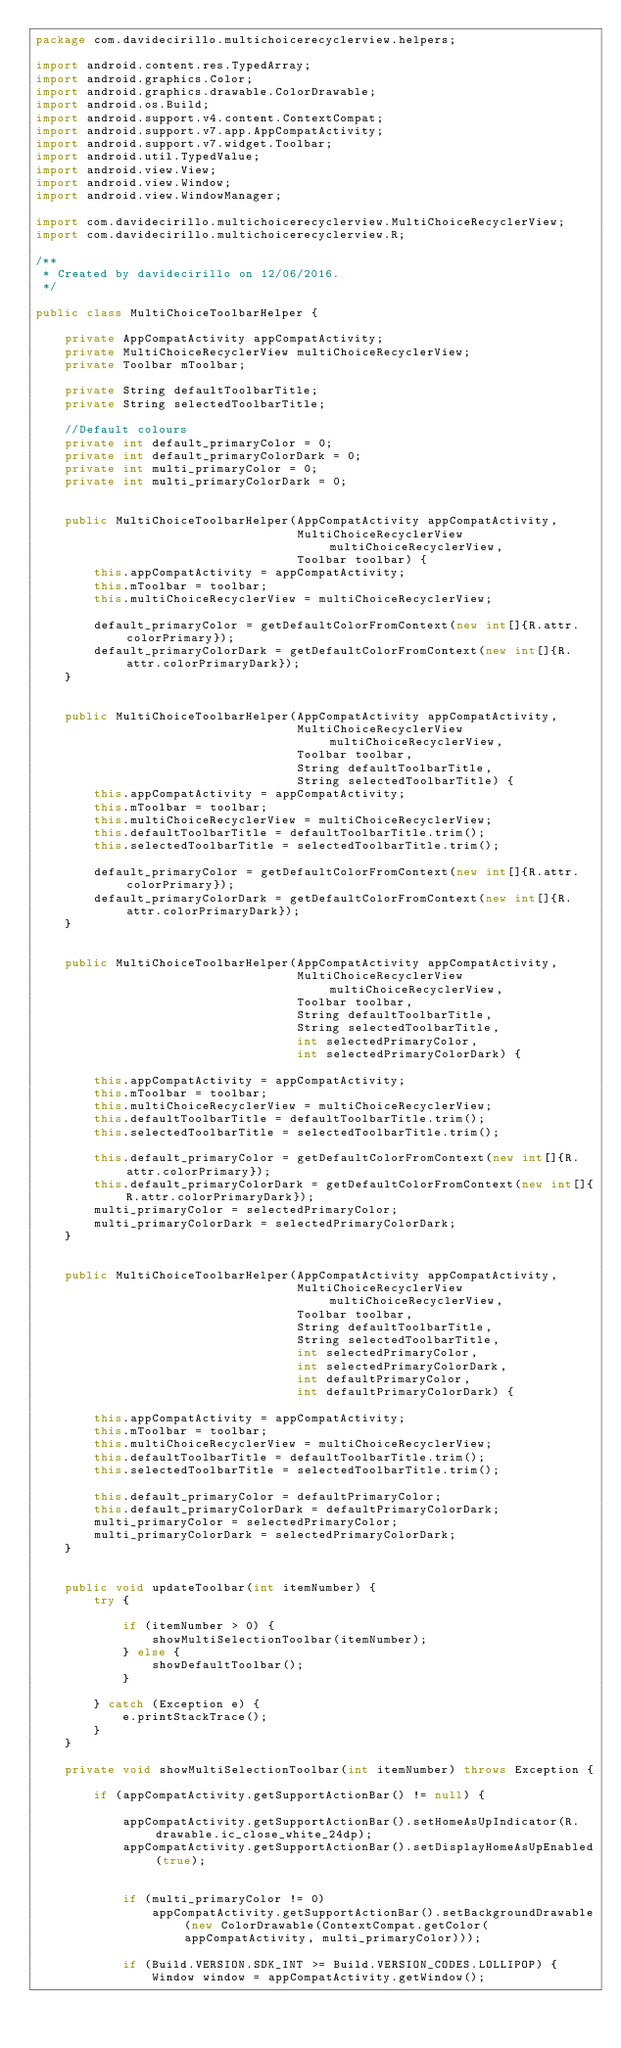Convert code to text. <code><loc_0><loc_0><loc_500><loc_500><_Java_>package com.davidecirillo.multichoicerecyclerview.helpers;

import android.content.res.TypedArray;
import android.graphics.Color;
import android.graphics.drawable.ColorDrawable;
import android.os.Build;
import android.support.v4.content.ContextCompat;
import android.support.v7.app.AppCompatActivity;
import android.support.v7.widget.Toolbar;
import android.util.TypedValue;
import android.view.View;
import android.view.Window;
import android.view.WindowManager;

import com.davidecirillo.multichoicerecyclerview.MultiChoiceRecyclerView;
import com.davidecirillo.multichoicerecyclerview.R;

/**
 * Created by davidecirillo on 12/06/2016.
 */

public class MultiChoiceToolbarHelper {

    private AppCompatActivity appCompatActivity;
    private MultiChoiceRecyclerView multiChoiceRecyclerView;
    private Toolbar mToolbar;

    private String defaultToolbarTitle;
    private String selectedToolbarTitle;

    //Default colours
    private int default_primaryColor = 0;
    private int default_primaryColorDark = 0;
    private int multi_primaryColor = 0;
    private int multi_primaryColorDark = 0;


    public MultiChoiceToolbarHelper(AppCompatActivity appCompatActivity,
                                    MultiChoiceRecyclerView multiChoiceRecyclerView,
                                    Toolbar toolbar) {
        this.appCompatActivity = appCompatActivity;
        this.mToolbar = toolbar;
        this.multiChoiceRecyclerView = multiChoiceRecyclerView;

        default_primaryColor = getDefaultColorFromContext(new int[]{R.attr.colorPrimary});
        default_primaryColorDark = getDefaultColorFromContext(new int[]{R.attr.colorPrimaryDark});
    }


    public MultiChoiceToolbarHelper(AppCompatActivity appCompatActivity,
                                    MultiChoiceRecyclerView multiChoiceRecyclerView,
                                    Toolbar toolbar,
                                    String defaultToolbarTitle,
                                    String selectedToolbarTitle) {
        this.appCompatActivity = appCompatActivity;
        this.mToolbar = toolbar;
        this.multiChoiceRecyclerView = multiChoiceRecyclerView;
        this.defaultToolbarTitle = defaultToolbarTitle.trim();
        this.selectedToolbarTitle = selectedToolbarTitle.trim();

        default_primaryColor = getDefaultColorFromContext(new int[]{R.attr.colorPrimary});
        default_primaryColorDark = getDefaultColorFromContext(new int[]{R.attr.colorPrimaryDark});
    }


    public MultiChoiceToolbarHelper(AppCompatActivity appCompatActivity,
                                    MultiChoiceRecyclerView multiChoiceRecyclerView,
                                    Toolbar toolbar,
                                    String defaultToolbarTitle,
                                    String selectedToolbarTitle,
                                    int selectedPrimaryColor,
                                    int selectedPrimaryColorDark) {

        this.appCompatActivity = appCompatActivity;
        this.mToolbar = toolbar;
        this.multiChoiceRecyclerView = multiChoiceRecyclerView;
        this.defaultToolbarTitle = defaultToolbarTitle.trim();
        this.selectedToolbarTitle = selectedToolbarTitle.trim();

        this.default_primaryColor = getDefaultColorFromContext(new int[]{R.attr.colorPrimary});
        this.default_primaryColorDark = getDefaultColorFromContext(new int[]{R.attr.colorPrimaryDark});
        multi_primaryColor = selectedPrimaryColor;
        multi_primaryColorDark = selectedPrimaryColorDark;
    }


    public MultiChoiceToolbarHelper(AppCompatActivity appCompatActivity,
                                    MultiChoiceRecyclerView multiChoiceRecyclerView,
                                    Toolbar toolbar,
                                    String defaultToolbarTitle,
                                    String selectedToolbarTitle,
                                    int selectedPrimaryColor,
                                    int selectedPrimaryColorDark,
                                    int defaultPrimaryColor,
                                    int defaultPrimaryColorDark) {

        this.appCompatActivity = appCompatActivity;
        this.mToolbar = toolbar;
        this.multiChoiceRecyclerView = multiChoiceRecyclerView;
        this.defaultToolbarTitle = defaultToolbarTitle.trim();
        this.selectedToolbarTitle = selectedToolbarTitle.trim();

        this.default_primaryColor = defaultPrimaryColor;
        this.default_primaryColorDark = defaultPrimaryColorDark;
        multi_primaryColor = selectedPrimaryColor;
        multi_primaryColorDark = selectedPrimaryColorDark;
    }


    public void updateToolbar(int itemNumber) {
        try {

            if (itemNumber > 0) {
                showMultiSelectionToolbar(itemNumber);
            } else {
                showDefaultToolbar();
            }

        } catch (Exception e) {
            e.printStackTrace();
        }
    }

    private void showMultiSelectionToolbar(int itemNumber) throws Exception {

        if (appCompatActivity.getSupportActionBar() != null) {

            appCompatActivity.getSupportActionBar().setHomeAsUpIndicator(R.drawable.ic_close_white_24dp);
            appCompatActivity.getSupportActionBar().setDisplayHomeAsUpEnabled(true);


            if (multi_primaryColor != 0)
                appCompatActivity.getSupportActionBar().setBackgroundDrawable(new ColorDrawable(ContextCompat.getColor(appCompatActivity, multi_primaryColor)));

            if (Build.VERSION.SDK_INT >= Build.VERSION_CODES.LOLLIPOP) {
                Window window = appCompatActivity.getWindow();</code> 